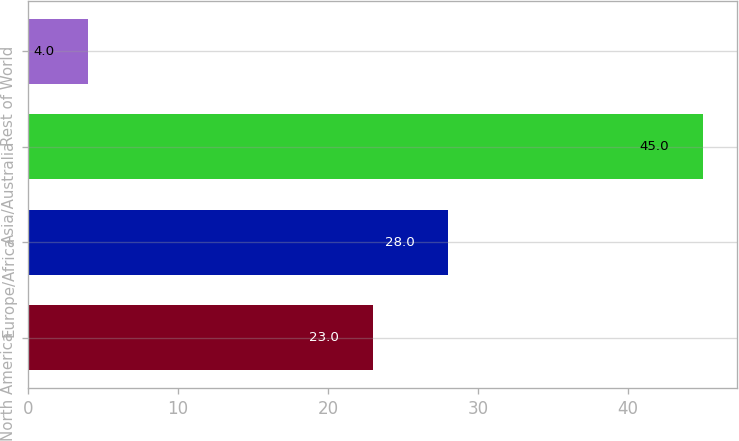Convert chart. <chart><loc_0><loc_0><loc_500><loc_500><bar_chart><fcel>North America<fcel>Europe/Africa<fcel>Asia/Australia<fcel>Rest of World<nl><fcel>23<fcel>28<fcel>45<fcel>4<nl></chart> 